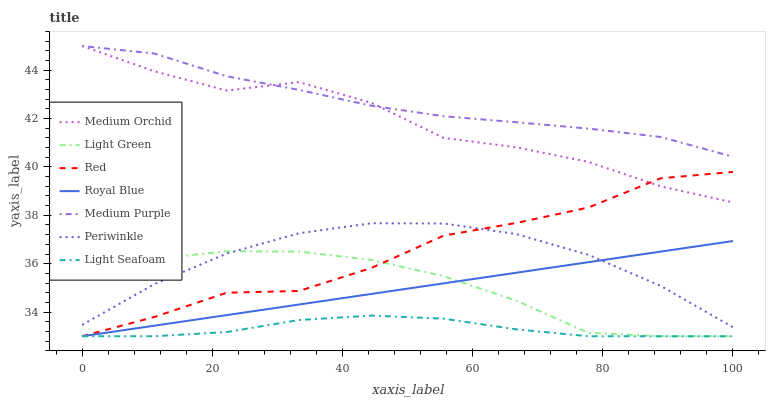Does Light Seafoam have the minimum area under the curve?
Answer yes or no. Yes. Does Medium Purple have the maximum area under the curve?
Answer yes or no. Yes. Does Royal Blue have the minimum area under the curve?
Answer yes or no. No. Does Royal Blue have the maximum area under the curve?
Answer yes or no. No. Is Royal Blue the smoothest?
Answer yes or no. Yes. Is Medium Orchid the roughest?
Answer yes or no. Yes. Is Medium Purple the smoothest?
Answer yes or no. No. Is Medium Purple the roughest?
Answer yes or no. No. Does Royal Blue have the lowest value?
Answer yes or no. Yes. Does Medium Purple have the lowest value?
Answer yes or no. No. Does Medium Purple have the highest value?
Answer yes or no. Yes. Does Royal Blue have the highest value?
Answer yes or no. No. Is Light Green less than Medium Orchid?
Answer yes or no. Yes. Is Periwinkle greater than Light Seafoam?
Answer yes or no. Yes. Does Royal Blue intersect Light Green?
Answer yes or no. Yes. Is Royal Blue less than Light Green?
Answer yes or no. No. Is Royal Blue greater than Light Green?
Answer yes or no. No. Does Light Green intersect Medium Orchid?
Answer yes or no. No. 